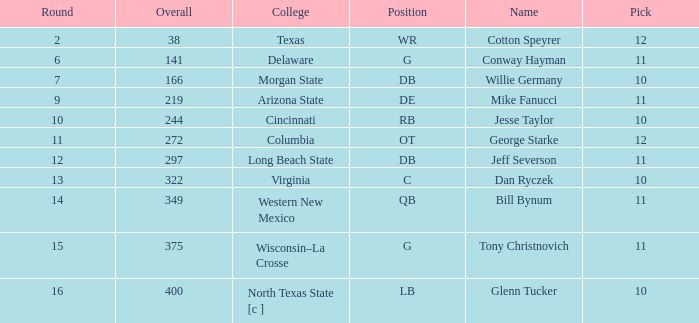What is the lowest round for an overall pick of 349 with a pick number in the round over 11? None. 